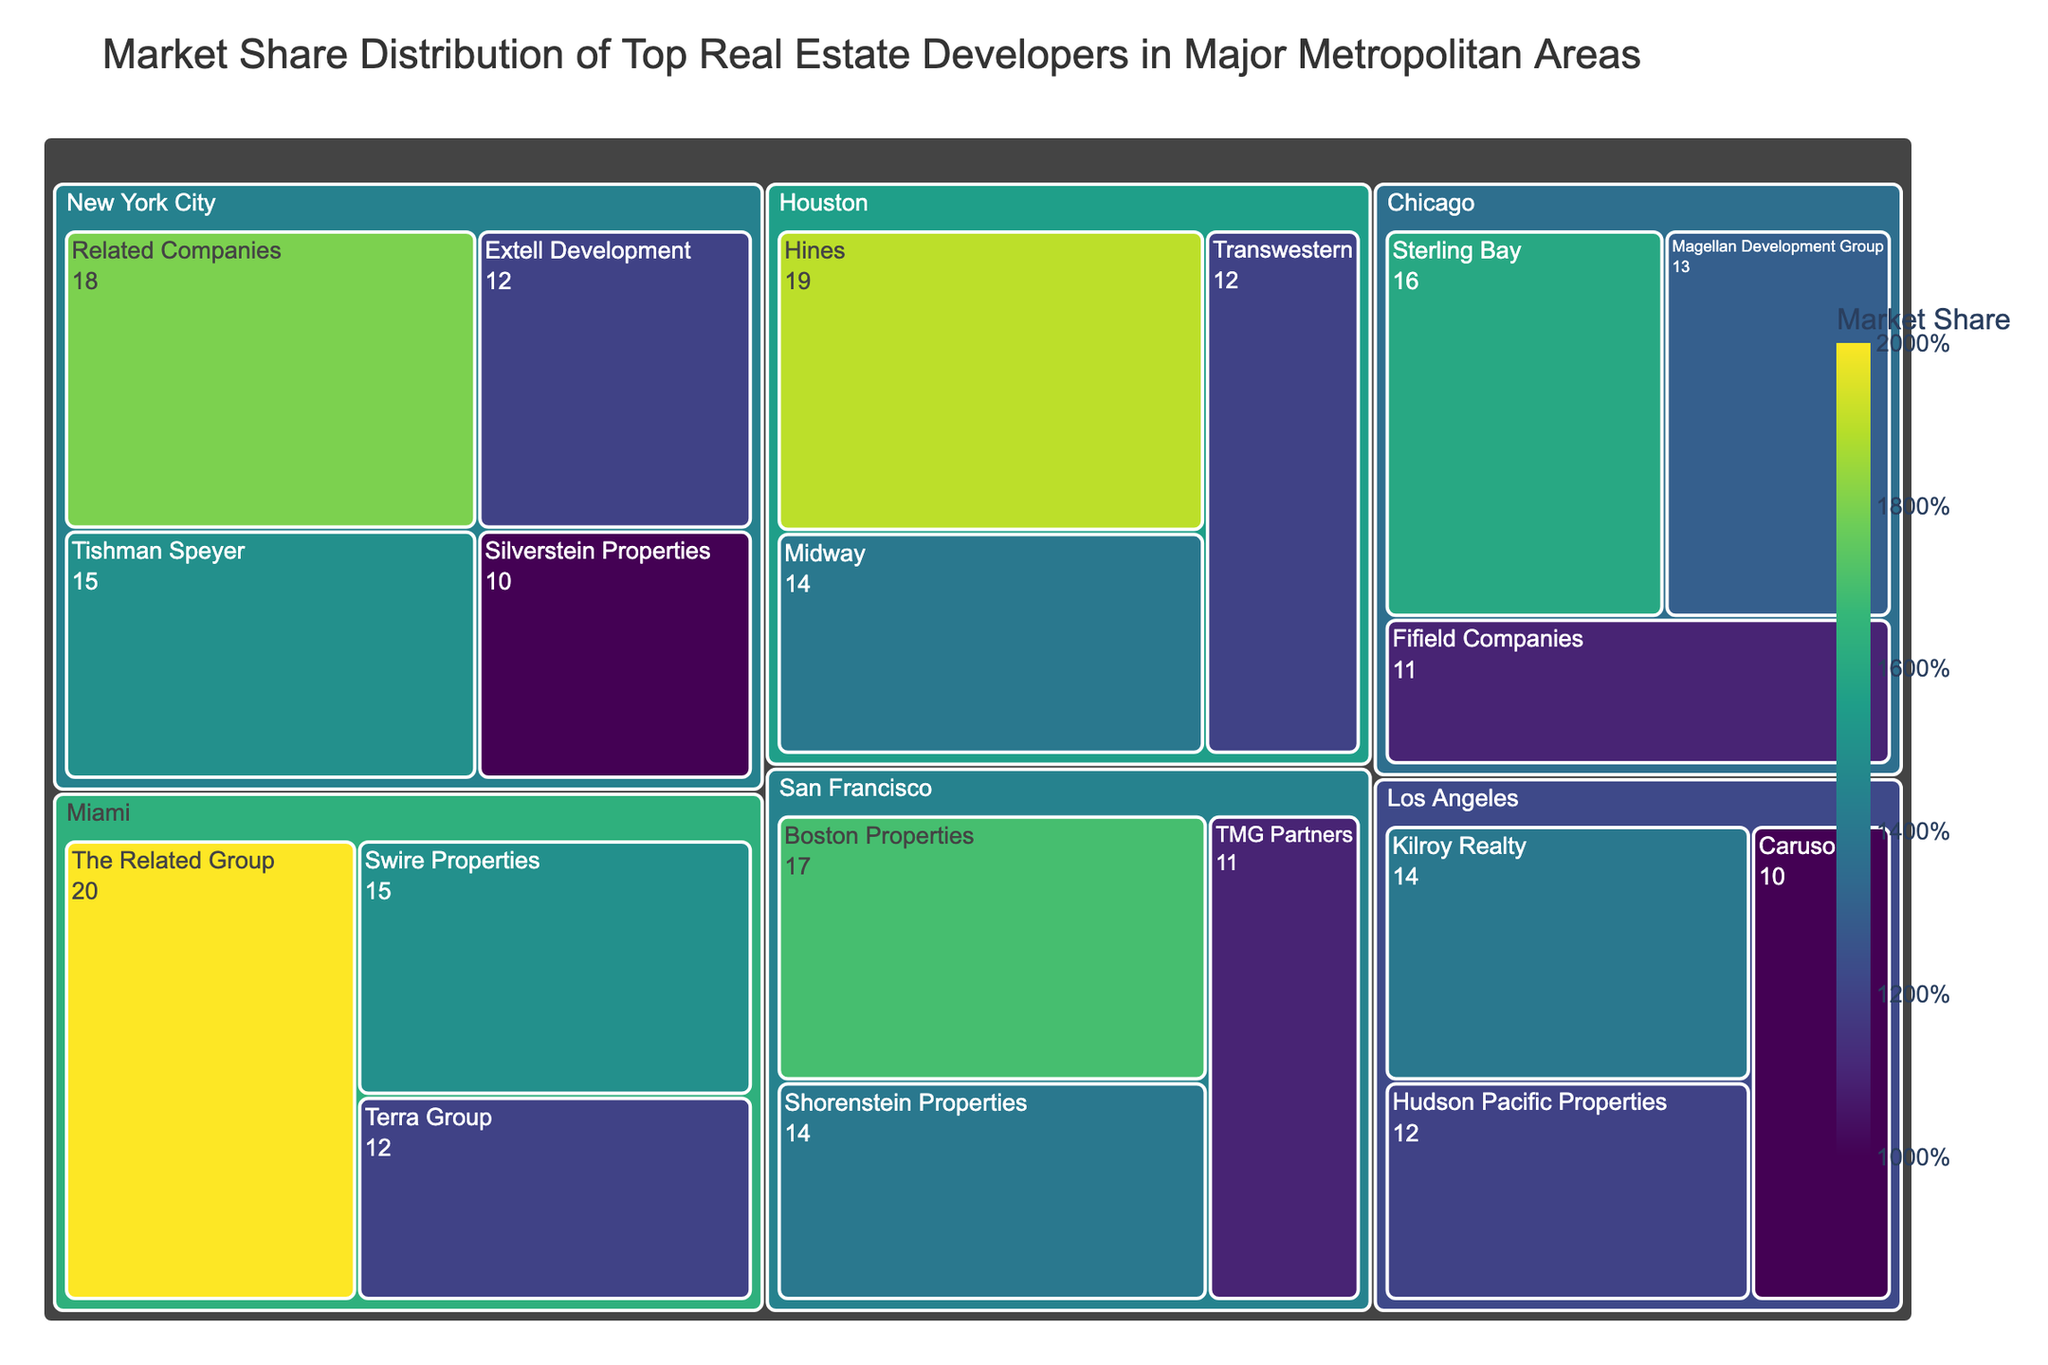What's the city with the highest market share for a single developer? Look for the largest block in the treemap that represents a single developer's market share. In Miami, The Related Group has the highest share at 20%.
Answer: Miami Which developer has the largest market share in Chicago? Examine the Chicago section in the treemap and identify the developer with the biggest block. Sterling Bay has the largest market share at 16%.
Answer: Sterling Bay How does the market share of Tishman Speyer in New York City compare to that of Shorenstein Properties in San Francisco? Look at the shares for Tishman Speyer in New York City (15%) and Shorenstein Properties in San Francisco (14%). Tishman Speyer has a 1% higher market share.
Answer: Tishman Speyer has 1% more What is the combined market share of all developers in Los Angeles? Sum the shares of all developers in Los Angeles: Kilroy Realty (14%), Hudson Pacific Properties (12%), and Caruso (10%). The combined share is 14 + 12 + 10 = 36%.
Answer: 36% Which city has the most evenly distributed market share among its top developers? Compare the size of blocks within each city to see where they are most similar in size. San Francisco's shares—Boston Properties (17%), Shorenstein Properties (14%), and TMG Partners (11%)—are relatively close to each other.
Answer: San Francisco Which developer has the smallest market share in the overall treemap? Identify the smallest block representing any developer's market share within the treemap. Caruso in Los Angeles holds the smallest share at 10%.
Answer: Caruso What total market share is controlled by developers in New York City? Add the market shares of all developers in New York City: Related Companies (18%), Tishman Speyer (15%), Extell Development (12%), Silverstein Properties (10%). The sum is 18 + 15 + 12 + 10 = 55%.
Answer: 55% 